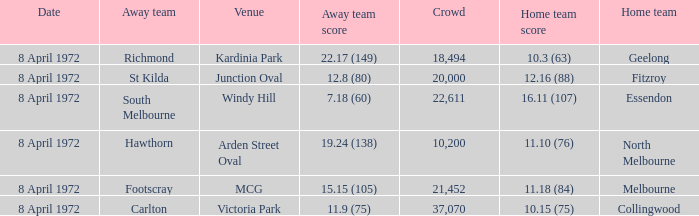Which Venue has a Home team of geelong? Kardinia Park. 